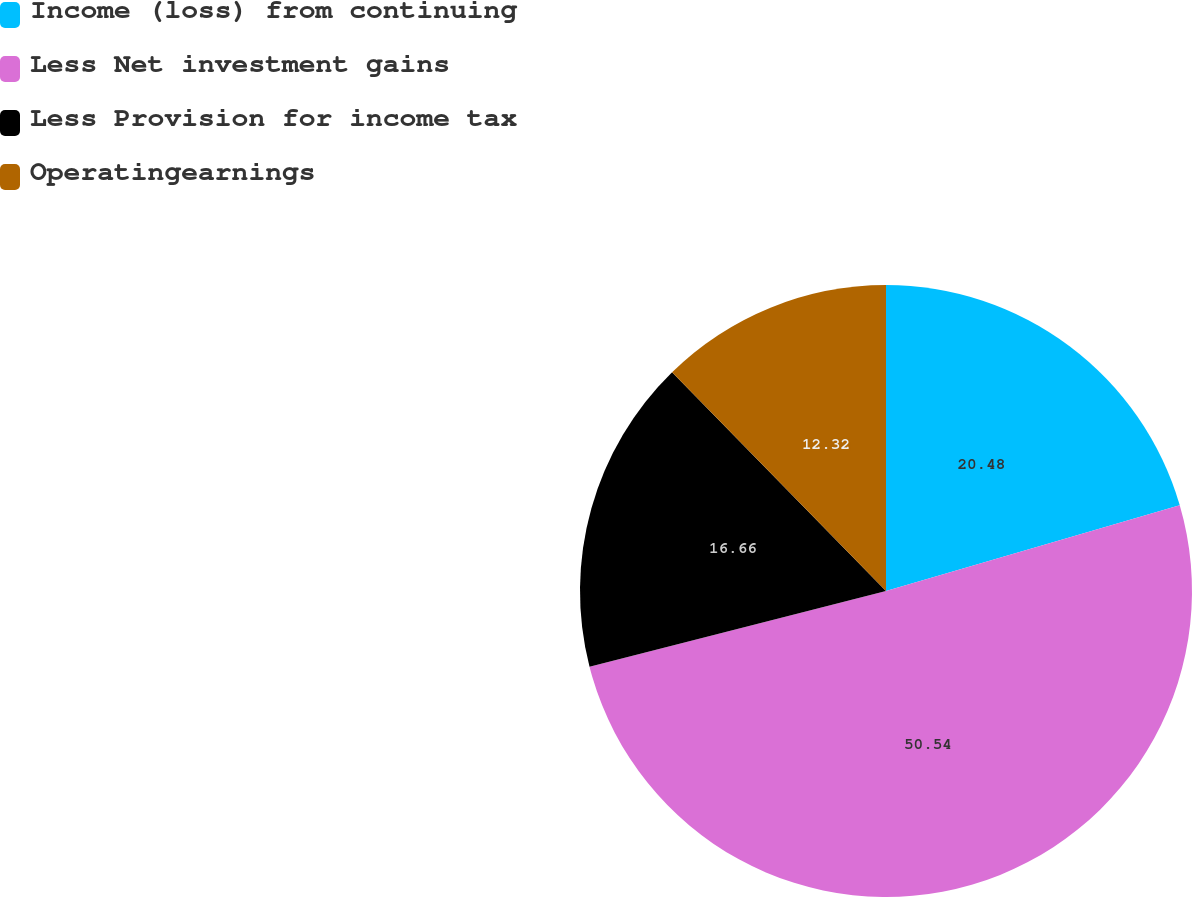<chart> <loc_0><loc_0><loc_500><loc_500><pie_chart><fcel>Income (loss) from continuing<fcel>Less Net investment gains<fcel>Less Provision for income tax<fcel>Operatingearnings<nl><fcel>20.48%<fcel>50.54%<fcel>16.66%<fcel>12.32%<nl></chart> 